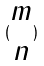Convert formula to latex. <formula><loc_0><loc_0><loc_500><loc_500>( \begin{matrix} m \\ n \end{matrix} )</formula> 